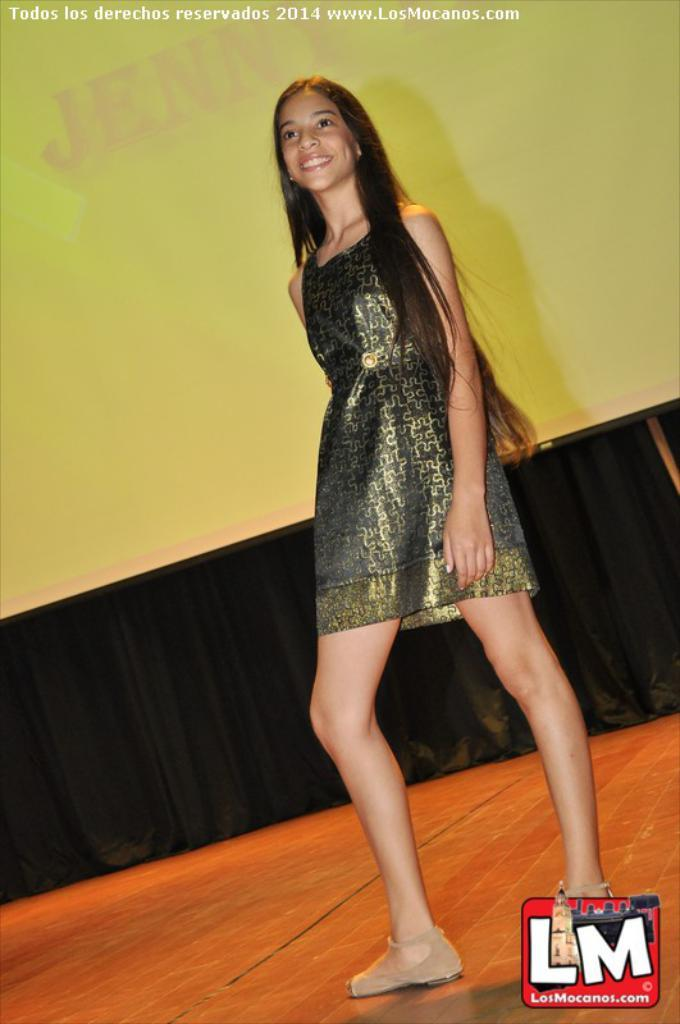Who is the main subject in the image? There is a lady person in the image. What is the lady person wearing? The lady person is wearing a green dress. Where is the lady person located in the image? The lady person is standing on a stage. What can be seen in the background of the image? There is a yellow and black color curtain in the background of the image. What type of reading material is the lady person holding in the image? There is no reading material visible in the image; the lady person is not holding anything. 